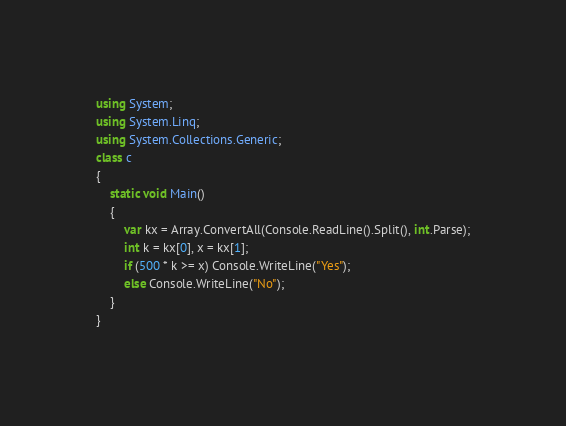Convert code to text. <code><loc_0><loc_0><loc_500><loc_500><_C#_>using System;
using System.Linq;
using System.Collections.Generic;
class c
{
    static void Main()
    {
        var kx = Array.ConvertAll(Console.ReadLine().Split(), int.Parse);
        int k = kx[0], x = kx[1];
        if (500 * k >= x) Console.WriteLine("Yes");
        else Console.WriteLine("No");
    }
}</code> 